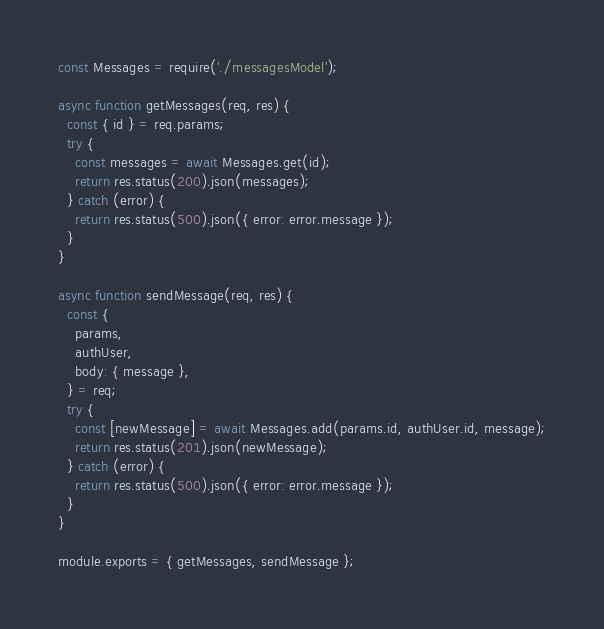<code> <loc_0><loc_0><loc_500><loc_500><_JavaScript_>const Messages = require('./messagesModel');

async function getMessages(req, res) {
  const { id } = req.params;
  try {
    const messages = await Messages.get(id);
    return res.status(200).json(messages);
  } catch (error) {
    return res.status(500).json({ error: error.message });
  }
}

async function sendMessage(req, res) {
  const {
    params,
    authUser,
    body: { message },
  } = req;
  try {
    const [newMessage] = await Messages.add(params.id, authUser.id, message);
    return res.status(201).json(newMessage);
  } catch (error) {
    return res.status(500).json({ error: error.message });
  }
}

module.exports = { getMessages, sendMessage };
</code> 